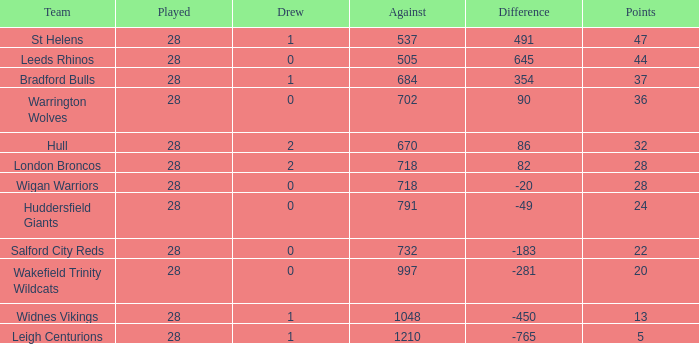What is the maximum disparity for the team that had fewer than 0 draws? None. 